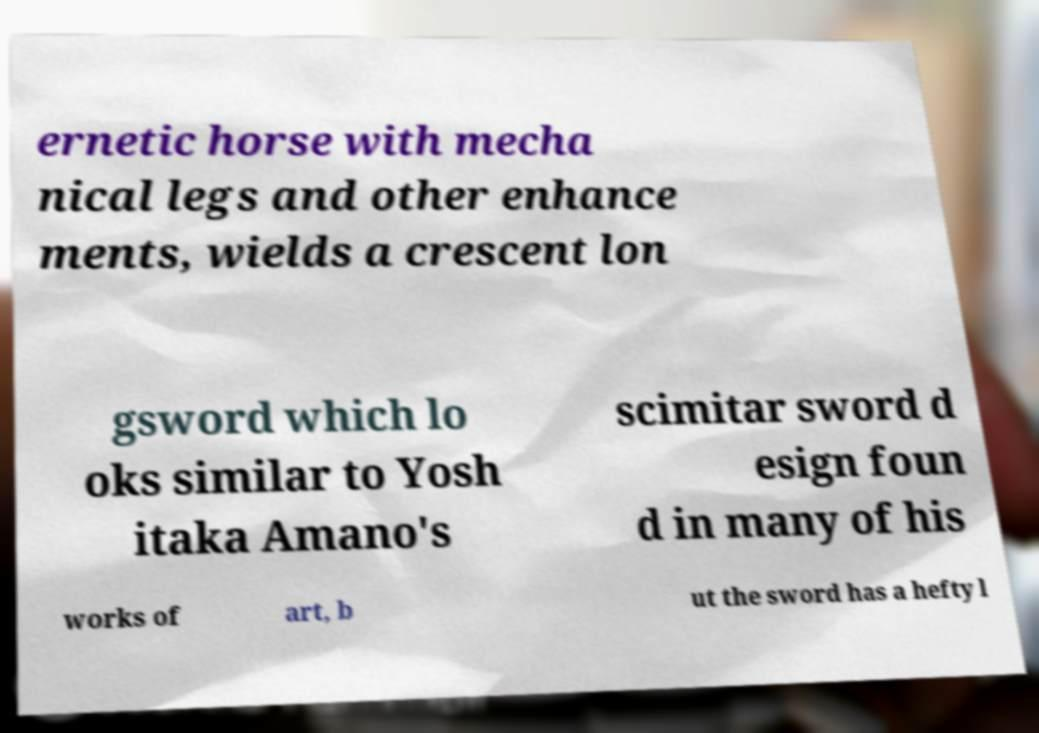Please identify and transcribe the text found in this image. ernetic horse with mecha nical legs and other enhance ments, wields a crescent lon gsword which lo oks similar to Yosh itaka Amano's scimitar sword d esign foun d in many of his works of art, b ut the sword has a hefty l 